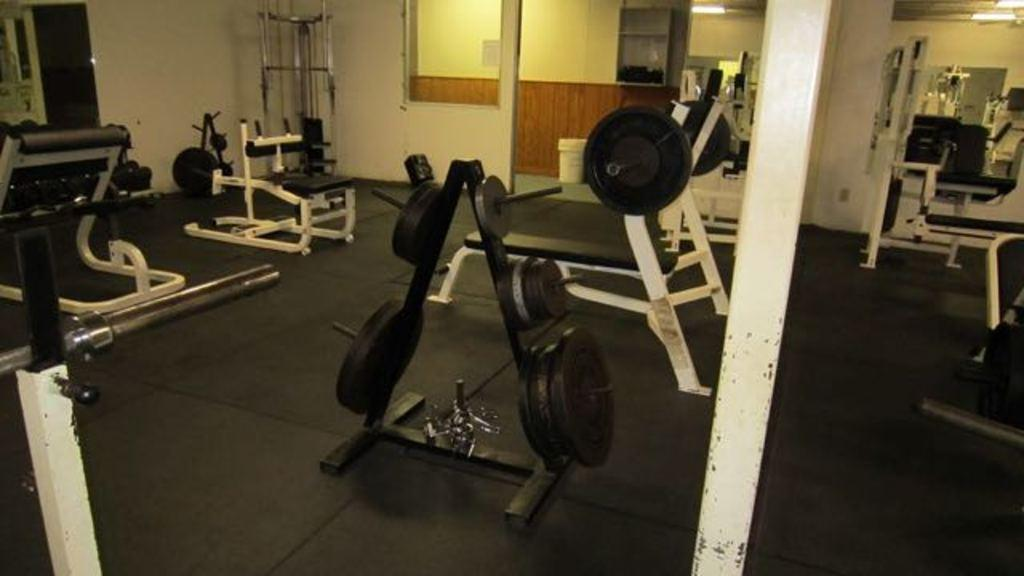What type of equipment can be seen in the image? There are gym equipment in the image. What specific items related to exercise are visible? There are weights in the image. What feature is present to help people see themselves while exercising? There are mirrors in the image. What type of lighting is present in the image? There are lights on the ceiling in the image. What color is the sweater worn by the person using the gym equipment in the image? There is no person wearing a sweater in the image; it only features gym equipment, weights, mirrors, and ceiling lights. 